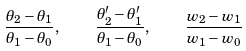Convert formula to latex. <formula><loc_0><loc_0><loc_500><loc_500>\frac { \theta _ { 2 } - \theta _ { 1 } } { \theta _ { 1 } - \theta _ { 0 } } , \quad \frac { \theta _ { 2 } ^ { \prime } - \theta _ { 1 } ^ { \prime } } { \theta _ { 1 } - \theta _ { 0 } } , \quad \frac { w _ { 2 } - w _ { 1 } } { w _ { 1 } - w _ { 0 } }</formula> 